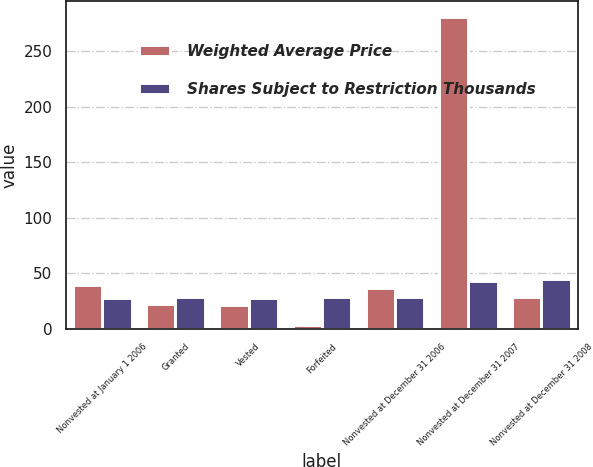Convert chart to OTSL. <chart><loc_0><loc_0><loc_500><loc_500><stacked_bar_chart><ecel><fcel>Nonvested at January 1 2006<fcel>Granted<fcel>Vested<fcel>Forfeited<fcel>Nonvested at December 31 2006<fcel>Nonvested at December 31 2007<fcel>Nonvested at December 31 2008<nl><fcel>Weighted Average Price<fcel>39.4<fcel>22.7<fcel>21.6<fcel>3.8<fcel>36.7<fcel>280.9<fcel>29.09<nl><fcel>Shares Subject to Restriction Thousands<fcel>27.81<fcel>29.09<fcel>27.62<fcel>29.09<fcel>28.58<fcel>42.9<fcel>45.29<nl></chart> 